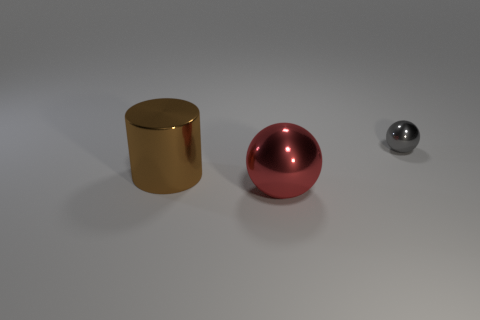Add 1 large metallic balls. How many objects exist? 4 Subtract all spheres. How many objects are left? 1 Add 2 large shiny objects. How many large shiny objects exist? 4 Subtract 0 brown cubes. How many objects are left? 3 Subtract all small yellow matte balls. Subtract all big brown cylinders. How many objects are left? 2 Add 3 metal cylinders. How many metal cylinders are left? 4 